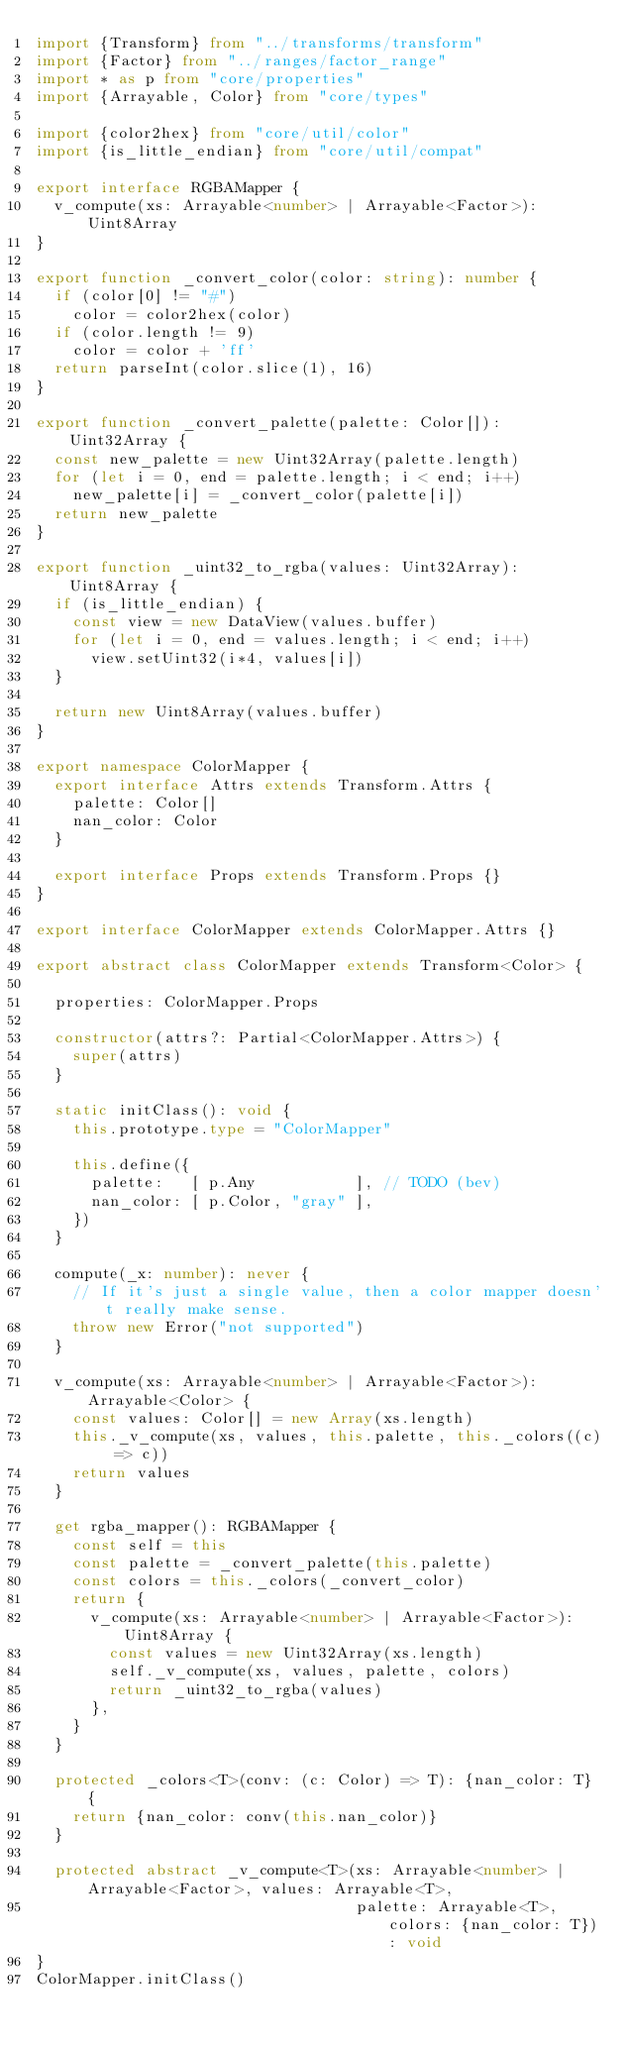<code> <loc_0><loc_0><loc_500><loc_500><_TypeScript_>import {Transform} from "../transforms/transform"
import {Factor} from "../ranges/factor_range"
import * as p from "core/properties"
import {Arrayable, Color} from "core/types"

import {color2hex} from "core/util/color"
import {is_little_endian} from "core/util/compat"

export interface RGBAMapper {
  v_compute(xs: Arrayable<number> | Arrayable<Factor>): Uint8Array
}

export function _convert_color(color: string): number {
  if (color[0] != "#")
    color = color2hex(color)
  if (color.length != 9)
    color = color + 'ff'
  return parseInt(color.slice(1), 16)
}

export function _convert_palette(palette: Color[]): Uint32Array {
  const new_palette = new Uint32Array(palette.length)
  for (let i = 0, end = palette.length; i < end; i++)
    new_palette[i] = _convert_color(palette[i])
  return new_palette
}

export function _uint32_to_rgba(values: Uint32Array): Uint8Array {
  if (is_little_endian) {
    const view = new DataView(values.buffer)
    for (let i = 0, end = values.length; i < end; i++)
      view.setUint32(i*4, values[i])
  }

  return new Uint8Array(values.buffer)
}

export namespace ColorMapper {
  export interface Attrs extends Transform.Attrs {
    palette: Color[]
    nan_color: Color
  }

  export interface Props extends Transform.Props {}
}

export interface ColorMapper extends ColorMapper.Attrs {}

export abstract class ColorMapper extends Transform<Color> {

  properties: ColorMapper.Props

  constructor(attrs?: Partial<ColorMapper.Attrs>) {
    super(attrs)
  }

  static initClass(): void {
    this.prototype.type = "ColorMapper"

    this.define({
      palette:   [ p.Any           ], // TODO (bev)
      nan_color: [ p.Color, "gray" ],
    })
  }

  compute(_x: number): never {
    // If it's just a single value, then a color mapper doesn't really make sense.
    throw new Error("not supported")
  }

  v_compute(xs: Arrayable<number> | Arrayable<Factor>): Arrayable<Color> {
    const values: Color[] = new Array(xs.length)
    this._v_compute(xs, values, this.palette, this._colors((c) => c))
    return values
  }

  get rgba_mapper(): RGBAMapper {
    const self = this
    const palette = _convert_palette(this.palette)
    const colors = this._colors(_convert_color)
    return {
      v_compute(xs: Arrayable<number> | Arrayable<Factor>): Uint8Array {
        const values = new Uint32Array(xs.length)
        self._v_compute(xs, values, palette, colors)
        return _uint32_to_rgba(values)
      },
    }
  }

  protected _colors<T>(conv: (c: Color) => T): {nan_color: T} {
    return {nan_color: conv(this.nan_color)}
  }

  protected abstract _v_compute<T>(xs: Arrayable<number> | Arrayable<Factor>, values: Arrayable<T>,
                                   palette: Arrayable<T>, colors: {nan_color: T}): void
}
ColorMapper.initClass()
</code> 